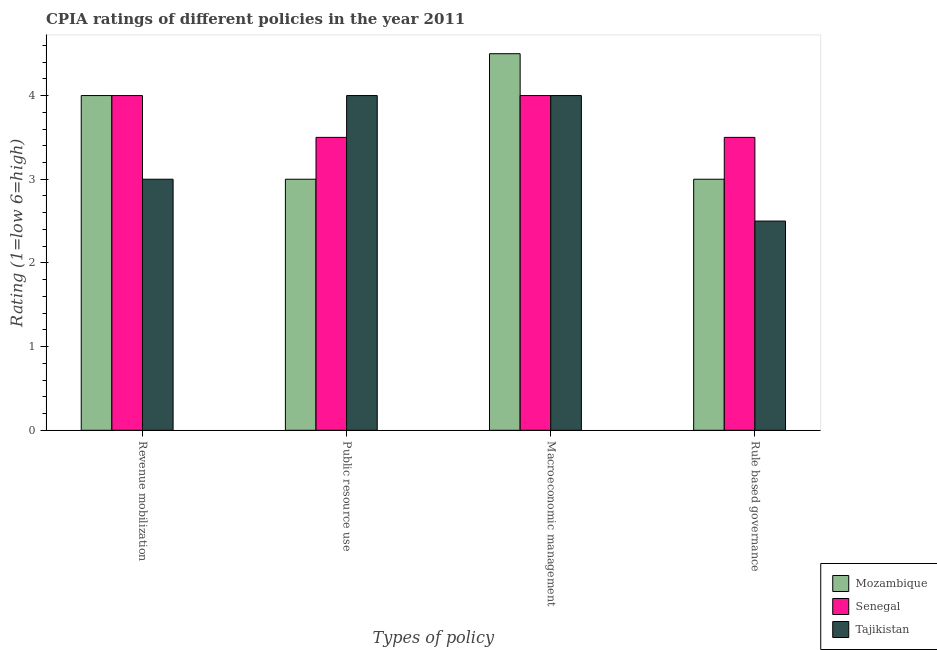How many different coloured bars are there?
Give a very brief answer. 3. Are the number of bars per tick equal to the number of legend labels?
Your answer should be compact. Yes. How many bars are there on the 1st tick from the left?
Offer a terse response. 3. How many bars are there on the 2nd tick from the right?
Provide a succinct answer. 3. What is the label of the 4th group of bars from the left?
Provide a succinct answer. Rule based governance. What is the cpia rating of public resource use in Senegal?
Your answer should be compact. 3.5. Across all countries, what is the minimum cpia rating of revenue mobilization?
Keep it short and to the point. 3. In which country was the cpia rating of revenue mobilization maximum?
Give a very brief answer. Mozambique. In which country was the cpia rating of public resource use minimum?
Provide a succinct answer. Mozambique. What is the difference between the cpia rating of rule based governance in Mozambique and the cpia rating of public resource use in Tajikistan?
Your answer should be compact. -1. What is the average cpia rating of revenue mobilization per country?
Give a very brief answer. 3.67. What is the ratio of the cpia rating of revenue mobilization in Senegal to that in Tajikistan?
Provide a succinct answer. 1.33. Is the difference between the cpia rating of revenue mobilization in Tajikistan and Mozambique greater than the difference between the cpia rating of macroeconomic management in Tajikistan and Mozambique?
Give a very brief answer. No. What does the 2nd bar from the left in Rule based governance represents?
Offer a terse response. Senegal. What does the 3rd bar from the right in Revenue mobilization represents?
Keep it short and to the point. Mozambique. Are all the bars in the graph horizontal?
Your response must be concise. No. How many countries are there in the graph?
Provide a short and direct response. 3. What is the difference between two consecutive major ticks on the Y-axis?
Your answer should be compact. 1. Does the graph contain any zero values?
Provide a short and direct response. No. How are the legend labels stacked?
Your response must be concise. Vertical. What is the title of the graph?
Offer a very short reply. CPIA ratings of different policies in the year 2011. What is the label or title of the X-axis?
Provide a short and direct response. Types of policy. What is the Rating (1=low 6=high) in Mozambique in Revenue mobilization?
Your response must be concise. 4. What is the Rating (1=low 6=high) of Tajikistan in Revenue mobilization?
Offer a very short reply. 3. What is the Rating (1=low 6=high) in Mozambique in Public resource use?
Give a very brief answer. 3. What is the Rating (1=low 6=high) in Senegal in Public resource use?
Offer a terse response. 3.5. What is the Rating (1=low 6=high) in Mozambique in Macroeconomic management?
Offer a very short reply. 4.5. What is the Rating (1=low 6=high) in Tajikistan in Macroeconomic management?
Offer a very short reply. 4. What is the Rating (1=low 6=high) of Mozambique in Rule based governance?
Your answer should be very brief. 3. What is the Rating (1=low 6=high) in Senegal in Rule based governance?
Provide a succinct answer. 3.5. Across all Types of policy, what is the maximum Rating (1=low 6=high) of Mozambique?
Offer a terse response. 4.5. Across all Types of policy, what is the minimum Rating (1=low 6=high) in Senegal?
Ensure brevity in your answer.  3.5. What is the total Rating (1=low 6=high) of Senegal in the graph?
Your answer should be very brief. 15. What is the difference between the Rating (1=low 6=high) of Mozambique in Revenue mobilization and that in Macroeconomic management?
Give a very brief answer. -0.5. What is the difference between the Rating (1=low 6=high) in Senegal in Revenue mobilization and that in Rule based governance?
Provide a short and direct response. 0.5. What is the difference between the Rating (1=low 6=high) of Tajikistan in Revenue mobilization and that in Rule based governance?
Offer a terse response. 0.5. What is the difference between the Rating (1=low 6=high) in Mozambique in Public resource use and that in Macroeconomic management?
Ensure brevity in your answer.  -1.5. What is the difference between the Rating (1=low 6=high) in Tajikistan in Public resource use and that in Macroeconomic management?
Provide a succinct answer. 0. What is the difference between the Rating (1=low 6=high) of Tajikistan in Public resource use and that in Rule based governance?
Your answer should be very brief. 1.5. What is the difference between the Rating (1=low 6=high) in Mozambique in Revenue mobilization and the Rating (1=low 6=high) in Tajikistan in Public resource use?
Keep it short and to the point. 0. What is the difference between the Rating (1=low 6=high) of Mozambique in Revenue mobilization and the Rating (1=low 6=high) of Tajikistan in Macroeconomic management?
Provide a short and direct response. 0. What is the difference between the Rating (1=low 6=high) of Senegal in Revenue mobilization and the Rating (1=low 6=high) of Tajikistan in Macroeconomic management?
Provide a succinct answer. 0. What is the difference between the Rating (1=low 6=high) of Mozambique in Revenue mobilization and the Rating (1=low 6=high) of Tajikistan in Rule based governance?
Keep it short and to the point. 1.5. What is the difference between the Rating (1=low 6=high) of Senegal in Revenue mobilization and the Rating (1=low 6=high) of Tajikistan in Rule based governance?
Offer a terse response. 1.5. What is the difference between the Rating (1=low 6=high) of Mozambique in Public resource use and the Rating (1=low 6=high) of Senegal in Macroeconomic management?
Provide a succinct answer. -1. What is the difference between the Rating (1=low 6=high) of Mozambique in Public resource use and the Rating (1=low 6=high) of Tajikistan in Macroeconomic management?
Your answer should be compact. -1. What is the difference between the Rating (1=low 6=high) of Senegal in Public resource use and the Rating (1=low 6=high) of Tajikistan in Macroeconomic management?
Offer a very short reply. -0.5. What is the difference between the Rating (1=low 6=high) in Mozambique in Public resource use and the Rating (1=low 6=high) in Senegal in Rule based governance?
Offer a very short reply. -0.5. What is the difference between the Rating (1=low 6=high) in Mozambique in Public resource use and the Rating (1=low 6=high) in Tajikistan in Rule based governance?
Give a very brief answer. 0.5. What is the difference between the Rating (1=low 6=high) of Senegal in Public resource use and the Rating (1=low 6=high) of Tajikistan in Rule based governance?
Offer a very short reply. 1. What is the difference between the Rating (1=low 6=high) of Mozambique in Macroeconomic management and the Rating (1=low 6=high) of Senegal in Rule based governance?
Offer a terse response. 1. What is the difference between the Rating (1=low 6=high) in Mozambique in Macroeconomic management and the Rating (1=low 6=high) in Tajikistan in Rule based governance?
Provide a short and direct response. 2. What is the difference between the Rating (1=low 6=high) in Senegal in Macroeconomic management and the Rating (1=low 6=high) in Tajikistan in Rule based governance?
Make the answer very short. 1.5. What is the average Rating (1=low 6=high) of Mozambique per Types of policy?
Give a very brief answer. 3.62. What is the average Rating (1=low 6=high) in Senegal per Types of policy?
Your answer should be very brief. 3.75. What is the average Rating (1=low 6=high) in Tajikistan per Types of policy?
Your answer should be very brief. 3.38. What is the difference between the Rating (1=low 6=high) in Mozambique and Rating (1=low 6=high) in Tajikistan in Revenue mobilization?
Give a very brief answer. 1. What is the difference between the Rating (1=low 6=high) of Senegal and Rating (1=low 6=high) of Tajikistan in Public resource use?
Your response must be concise. -0.5. What is the ratio of the Rating (1=low 6=high) of Mozambique in Revenue mobilization to that in Public resource use?
Offer a terse response. 1.33. What is the ratio of the Rating (1=low 6=high) of Senegal in Revenue mobilization to that in Public resource use?
Offer a terse response. 1.14. What is the ratio of the Rating (1=low 6=high) in Mozambique in Revenue mobilization to that in Macroeconomic management?
Make the answer very short. 0.89. What is the ratio of the Rating (1=low 6=high) of Senegal in Revenue mobilization to that in Macroeconomic management?
Offer a very short reply. 1. What is the ratio of the Rating (1=low 6=high) in Tajikistan in Revenue mobilization to that in Macroeconomic management?
Your answer should be very brief. 0.75. What is the ratio of the Rating (1=low 6=high) of Senegal in Revenue mobilization to that in Rule based governance?
Your answer should be compact. 1.14. What is the ratio of the Rating (1=low 6=high) in Tajikistan in Revenue mobilization to that in Rule based governance?
Your answer should be very brief. 1.2. What is the ratio of the Rating (1=low 6=high) of Mozambique in Public resource use to that in Rule based governance?
Give a very brief answer. 1. What is the ratio of the Rating (1=low 6=high) in Tajikistan in Public resource use to that in Rule based governance?
Your answer should be compact. 1.6. What is the ratio of the Rating (1=low 6=high) in Mozambique in Macroeconomic management to that in Rule based governance?
Provide a short and direct response. 1.5. What is the ratio of the Rating (1=low 6=high) in Senegal in Macroeconomic management to that in Rule based governance?
Make the answer very short. 1.14. What is the difference between the highest and the second highest Rating (1=low 6=high) of Mozambique?
Offer a terse response. 0.5. What is the difference between the highest and the second highest Rating (1=low 6=high) of Senegal?
Your answer should be very brief. 0. What is the difference between the highest and the lowest Rating (1=low 6=high) in Mozambique?
Provide a succinct answer. 1.5. What is the difference between the highest and the lowest Rating (1=low 6=high) of Senegal?
Provide a succinct answer. 0.5. What is the difference between the highest and the lowest Rating (1=low 6=high) in Tajikistan?
Keep it short and to the point. 1.5. 